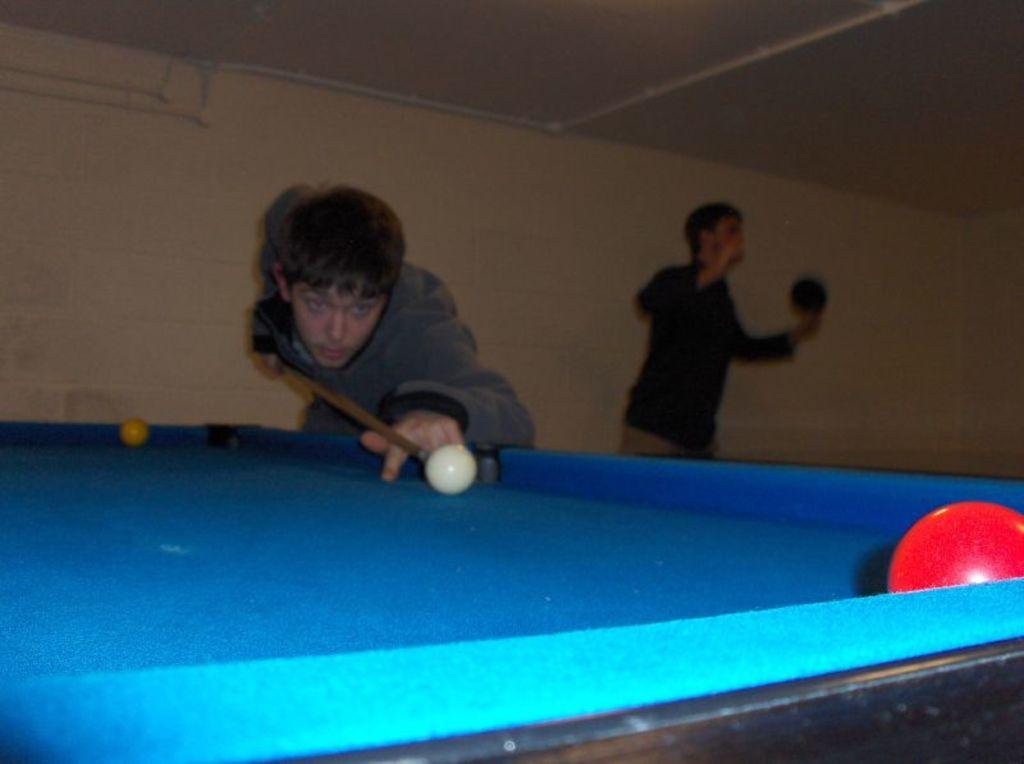What activity is the person in the image engaged in? There is a person playing snookers in the image. Can you describe the scene around the snookers player? There is another person beside the snookers player. What can be seen in the background of the image? There is a wall in the background of the image. What type of garden can be seen in the image? There is no garden present in the image; it features a person playing snookers and a wall in the background. 